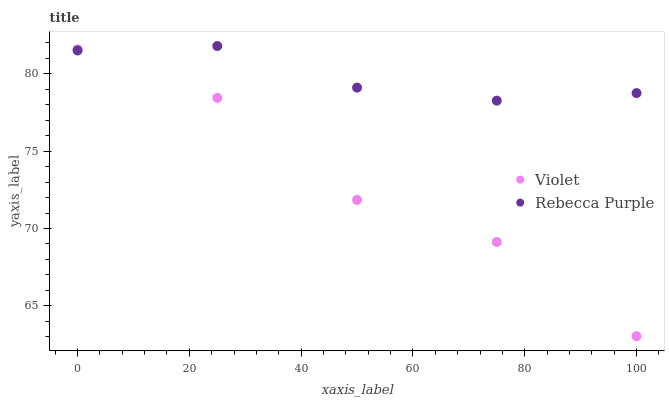Does Violet have the minimum area under the curve?
Answer yes or no. Yes. Does Rebecca Purple have the maximum area under the curve?
Answer yes or no. Yes. Does Violet have the maximum area under the curve?
Answer yes or no. No. Is Rebecca Purple the smoothest?
Answer yes or no. Yes. Is Violet the roughest?
Answer yes or no. Yes. Is Violet the smoothest?
Answer yes or no. No. Does Violet have the lowest value?
Answer yes or no. Yes. Does Rebecca Purple have the highest value?
Answer yes or no. Yes. Does Violet have the highest value?
Answer yes or no. No. Does Violet intersect Rebecca Purple?
Answer yes or no. Yes. Is Violet less than Rebecca Purple?
Answer yes or no. No. Is Violet greater than Rebecca Purple?
Answer yes or no. No. 